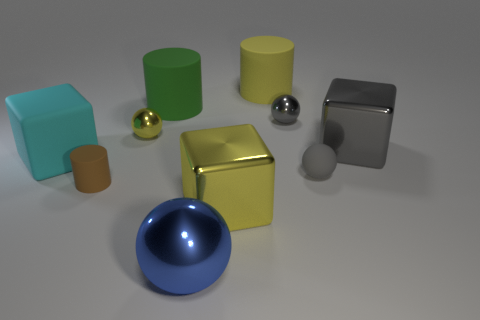Subtract all blocks. How many objects are left? 7 Add 3 small gray shiny balls. How many small gray shiny balls are left? 4 Add 3 small brown cylinders. How many small brown cylinders exist? 4 Subtract 0 brown blocks. How many objects are left? 10 Subtract all small shiny things. Subtract all big green things. How many objects are left? 7 